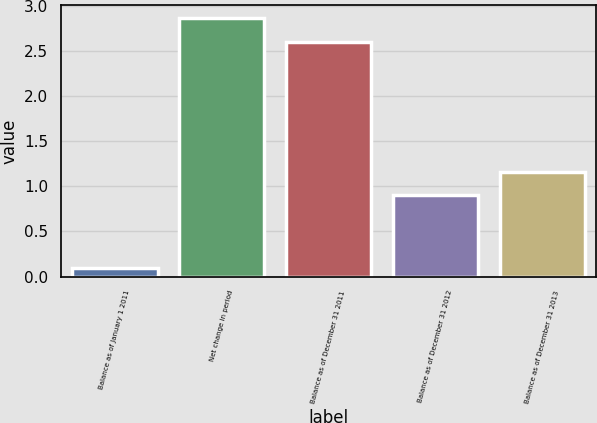Convert chart to OTSL. <chart><loc_0><loc_0><loc_500><loc_500><bar_chart><fcel>Balance as of January 1 2011<fcel>Net change in period<fcel>Balance as of December 31 2011<fcel>Balance as of December 31 2012<fcel>Balance as of December 31 2013<nl><fcel>0.1<fcel>2.86<fcel>2.6<fcel>0.9<fcel>1.16<nl></chart> 